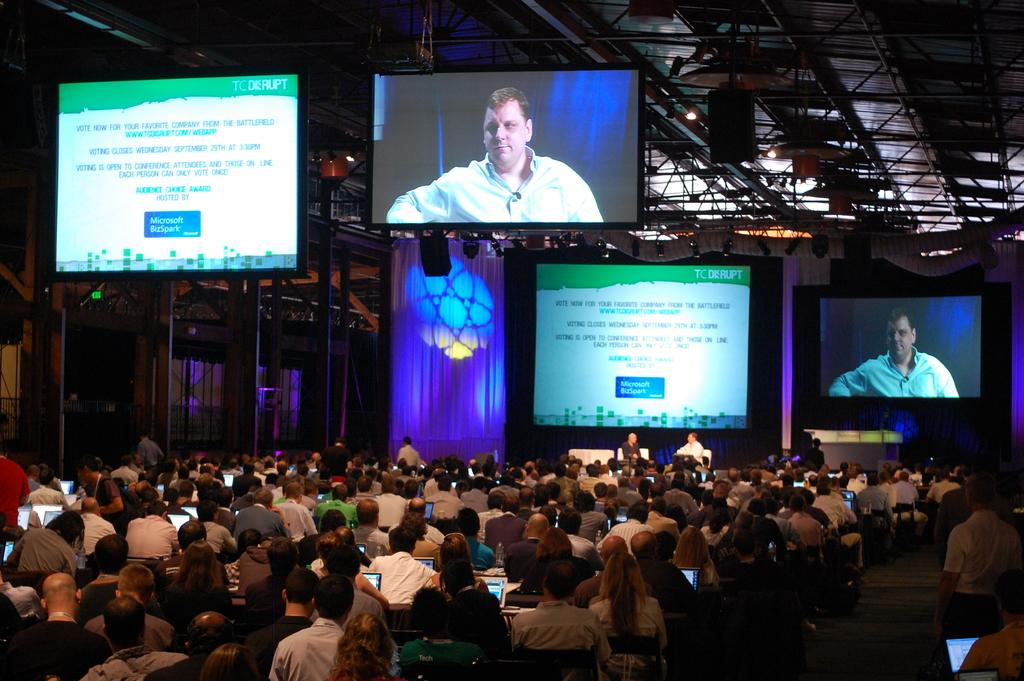<image>
Render a clear and concise summary of the photo. The two television screens above a large group of people talks about Microsoft. 